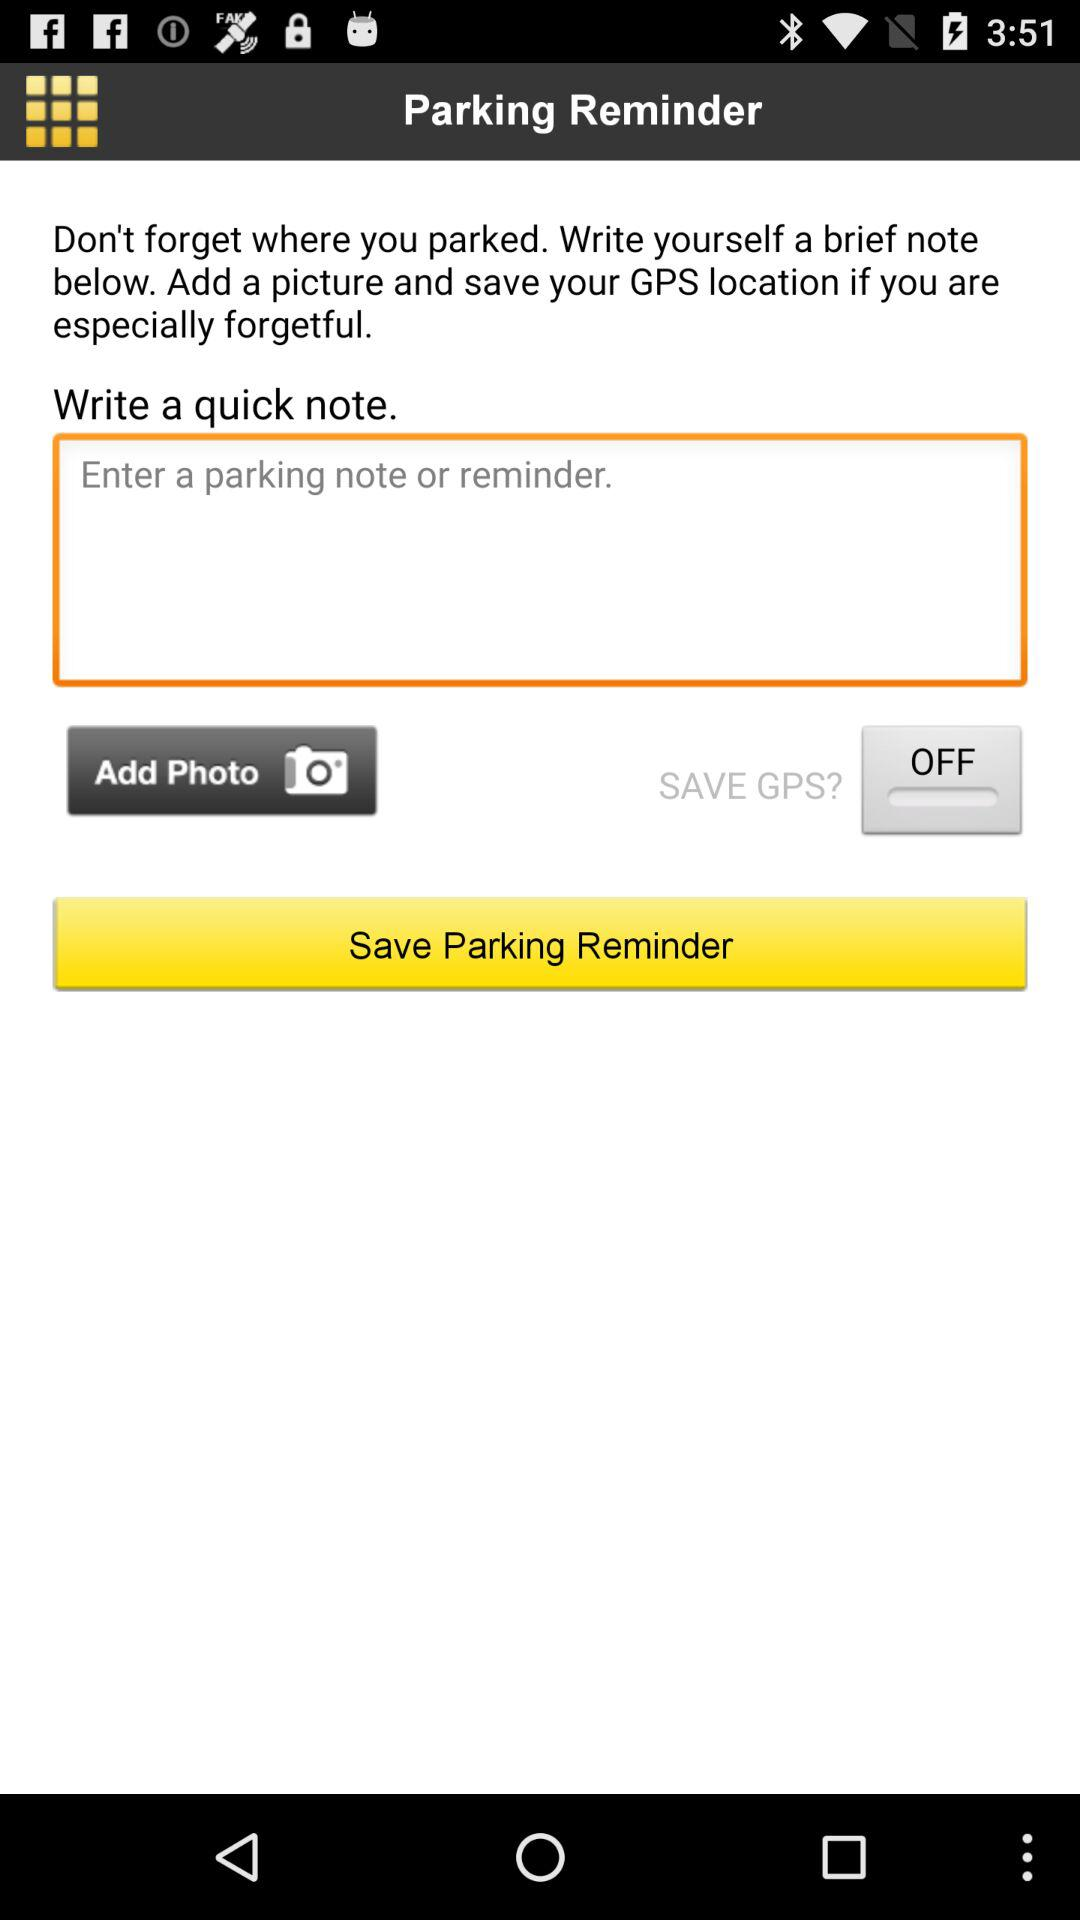What parking note is entered?
When the provided information is insufficient, respond with <no answer>. <no answer> 